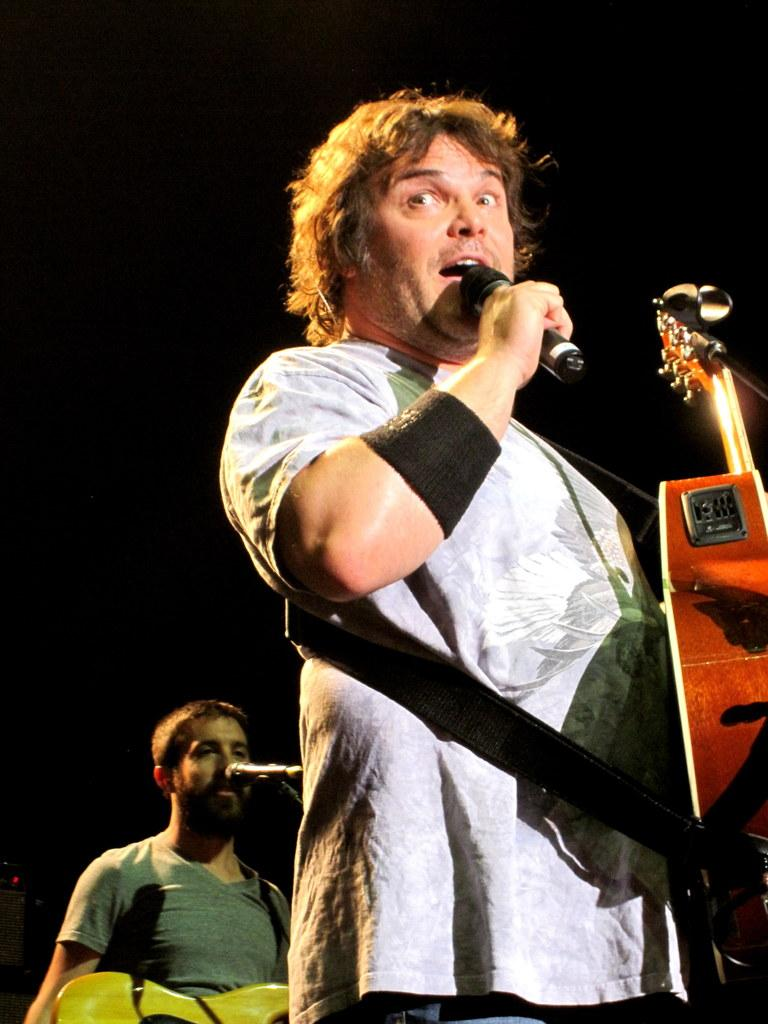What is the person in the image holding in their hands? The person in the image is holding a microphone and a guitar. Can you describe the other person in the image? There is another person in the background of the image holding a guitar. What type of hobbies does the goldfish in the image enjoy? There is no goldfish present in the image, so it is not possible to determine their hobbies. 